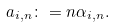Convert formula to latex. <formula><loc_0><loc_0><loc_500><loc_500>a _ { i , n } \colon = n \alpha _ { i , n } .</formula> 